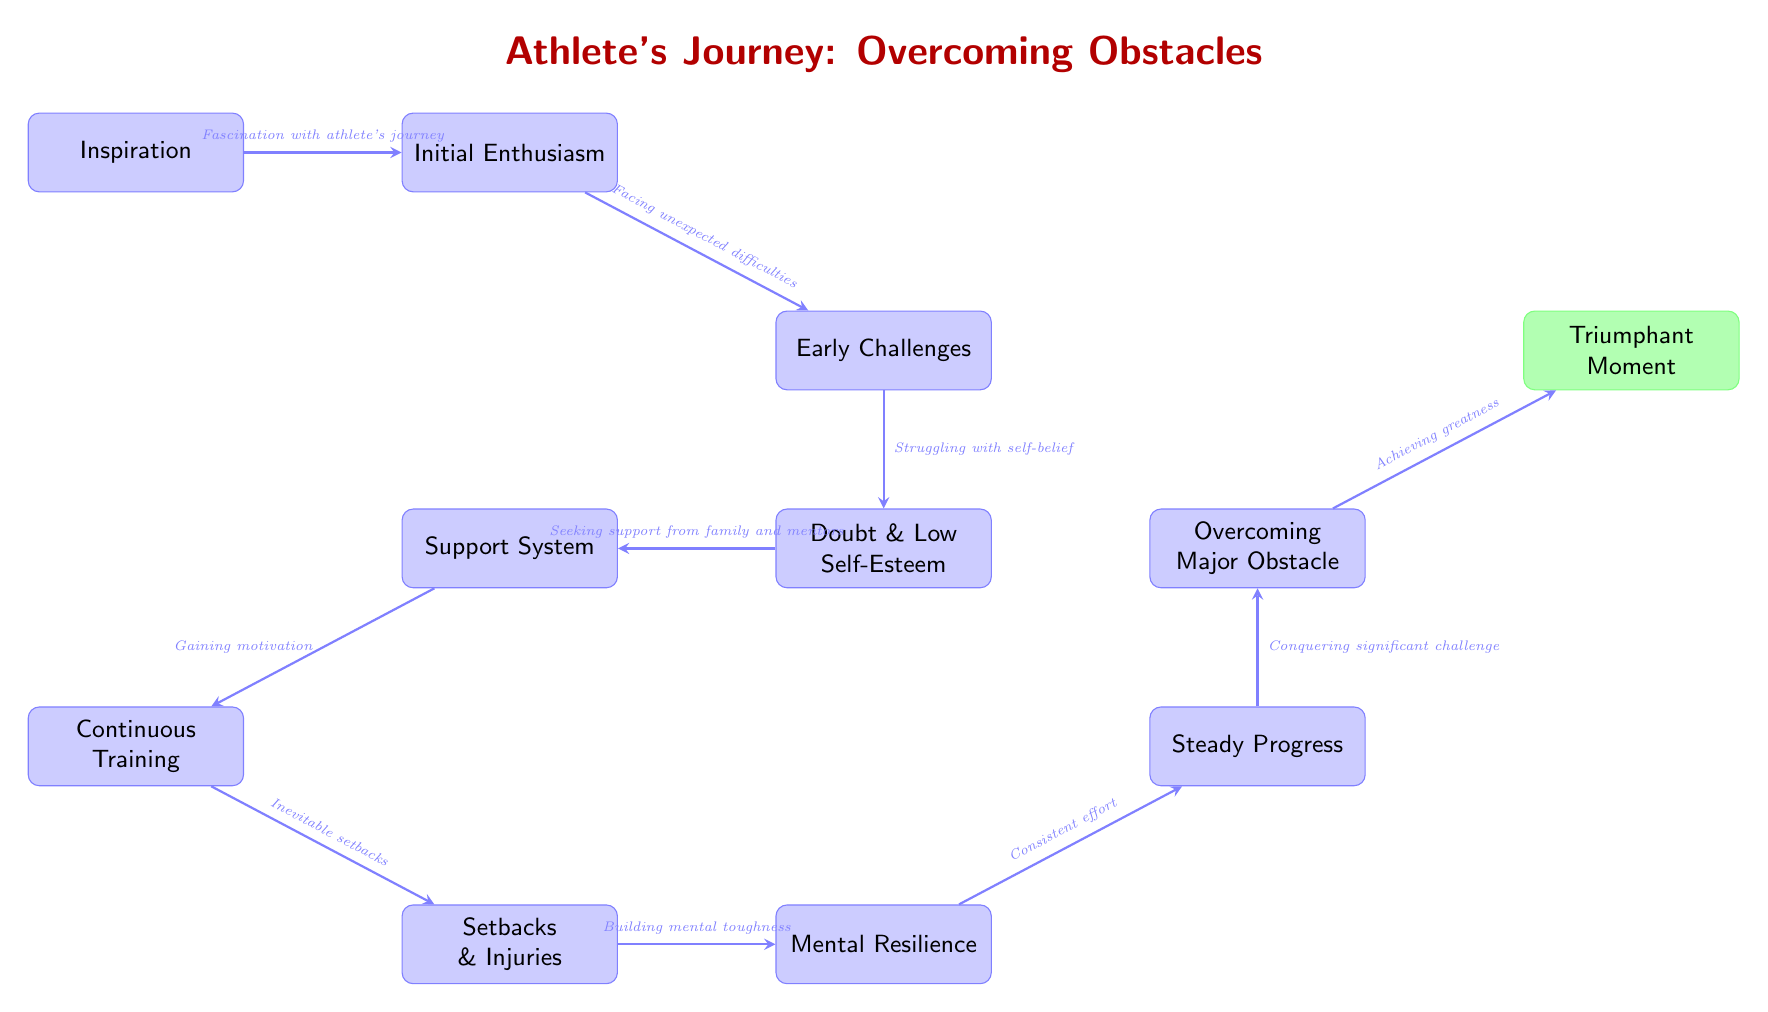What is the first node in the flowchart? The flowchart starts with the node labeled "Inspiration," which is the first step in the athlete's journey.
Answer: Inspiration How many nodes are in the flowchart? By counting all the distinct boxes in the flowchart, we can see that there are a total of 11 nodes, including the triumphant moment.
Answer: 11 What is the last step before the Triumphant Moment? The last step before reaching the "Triumphant Moment" is "Overcoming Major Obstacle," which leads directly to the final achievement.
Answer: Overcoming Major Obstacle What represents the most significant challenge overcome by athletes? The arrow connecting "Steady Progress" to "Overcoming Major Obstacle" indicates that the major challenge athletes face is depicted in this node.
Answer: Overcoming Major Obstacle What does the supportive node suggest athletes should seek? The node "Support System" implies that athletes should seek backing and encouragement from family and mentors to help overcome self-doubt.
Answer: Support How does an athlete build mental toughness? The flowchart shows that after experiencing setbacks and injuries, athletes build mental toughness through the node "Mental Resilience."
Answer: Mental Resilience What does the arrow from "Continuous Training" lead to? The arrow extends from "Continuous Training" to "Setbacks & Injuries," indicating that training often leads to facing challenges like injuries.
Answer: Setbacks & Injuries Which node indicates facing unexpected difficulties? The node labeled "Early Challenges" describes the stage where athletes start to encounter unexpected difficulties after their initial enthusiasm.
Answer: Early Challenges What is the relationship between "Initial Enthusiasm" and "Early Challenges"? The flow from "Initial Enthusiasm" to "Early Challenges" indicates that after the initial excitement, athletes typically confront early difficulties.
Answer: Facing unexpected difficulties 